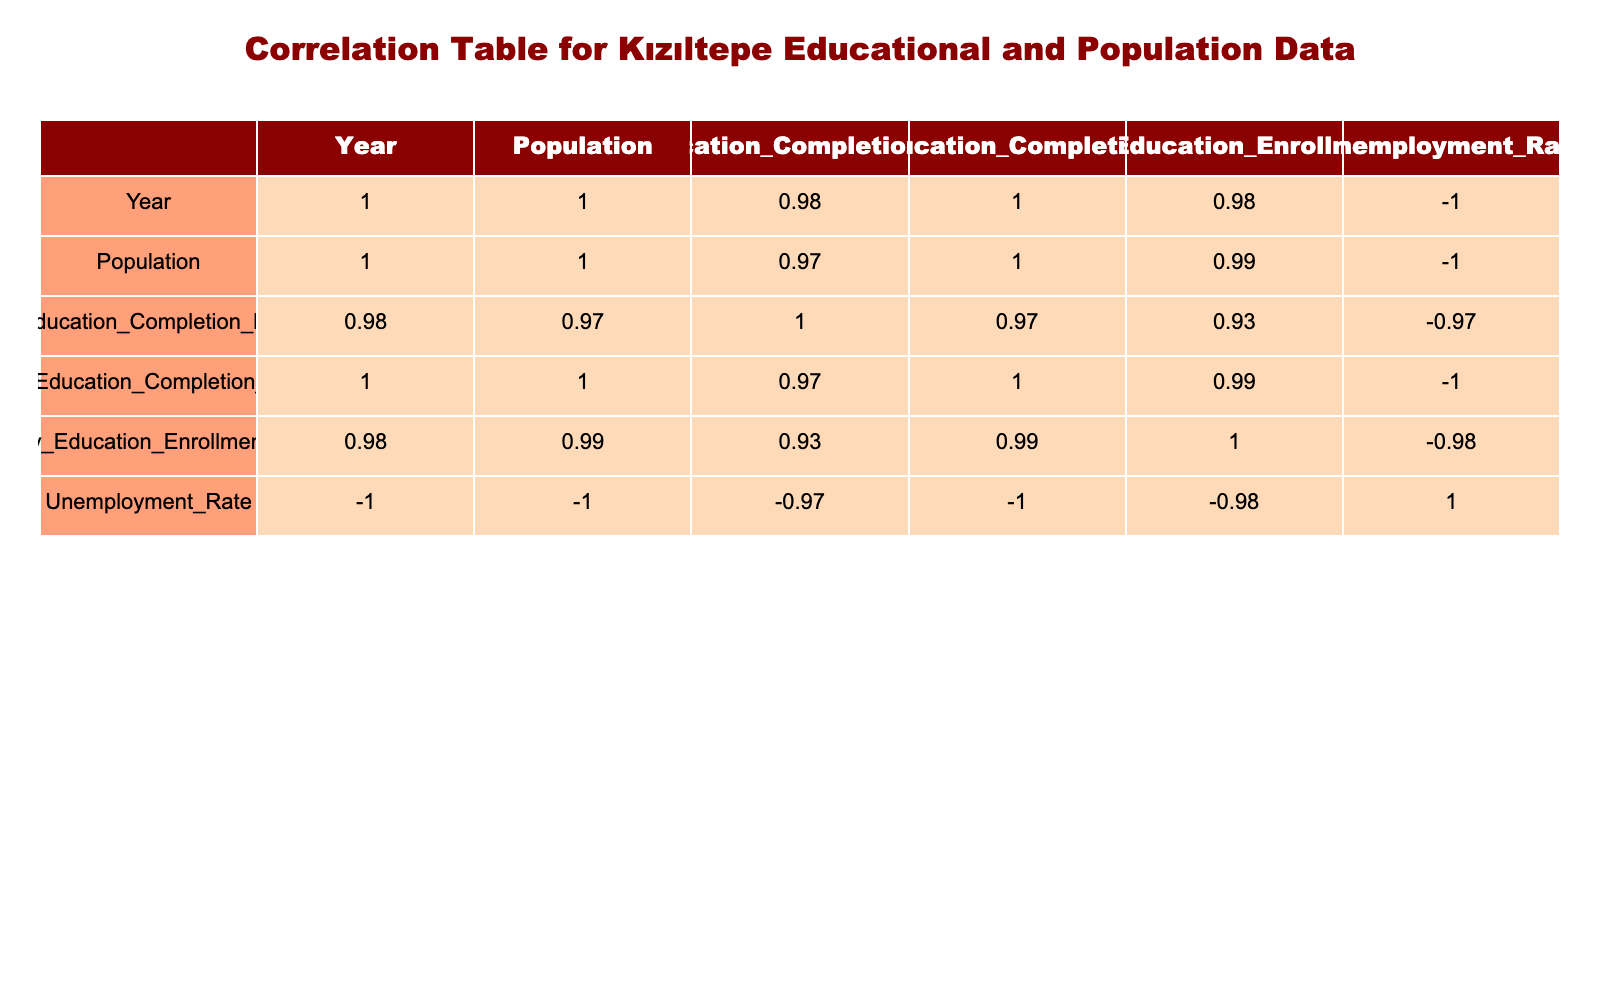What was the population in 2015? The table shows that the population in 2015 is listed in the corresponding row for that year. According to the table, the population in 2015 was 65000.
Answer: 65000 What is the primary education completion percentage in 2020? To find this, we look for the year 2020 in the table and check the corresponding value for primary education completion percentage, which is 92.
Answer: 92 Is the tertiary education enrollment rate higher in 2023 than in 2000? By comparing the values for tertiary education enrollment for both years from the table, we see that in 2023 it is 40 and in 2000 it is 10. Since 40 is greater than 10, the answer is yes.
Answer: Yes What is the average unemployment rate over the years listed? To calculate the average, we first identify the unemployment rates for all listed years: 20, 18, 15, 12, 10, and 8. Then, we sum them up: (20 + 18 + 15 + 12 + 10 + 8) = 83. We have 6 years, so we divide 83 by 6, which results in approximately 13.83.
Answer: 13.83 What is the difference in the primary education completion percentage between 2000 and 2023? The primary education completion percentage in 2000 is 80 and in 2023 it is 93. To find the difference, we subtract the earlier value from the later value: 93 - 80 = 13.
Answer: 13 Is the population expected to decrease from 2010 to 2023 based on the data? Looking at the population values from 2010 (60000) and 2023 (75000) in the table, we can see that the population has increased from 60000 to 75000, indicating an increase rather than a decrease. Therefore, the answer is no.
Answer: No What trend can be inferred about secondary education completion percentage from 2000 to 2023? By examining the secondary education completion percentages in the table, we observe it rises from 35 in 2000 to 60 in 2023. This consistent increase indicates a positive trend in secondary education completion over these years.
Answer: Increasing What is the highest tertiary education enrollment rate recorded in the table? Scanning through the tertiary education enrollment rate values from each year in the table, we find that the highest rate recorded is 40 in 2023.
Answer: 40 What is the unemployment rate in 2010? Referring to the row for the year 2010, we find the corresponding unemployment rate, which is 15.
Answer: 15 